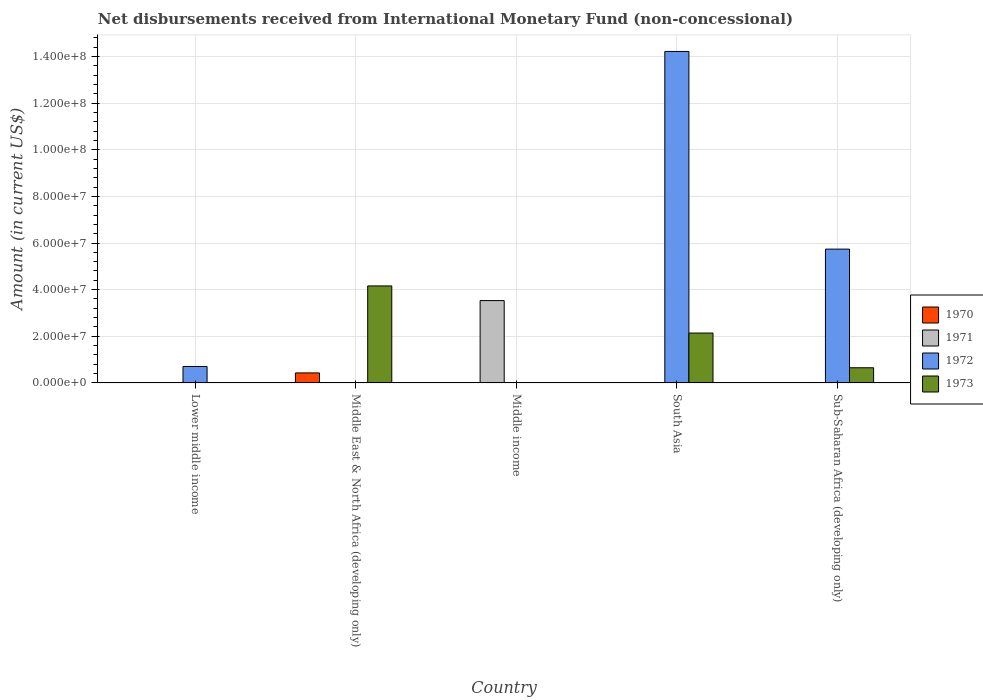What is the label of the 1st group of bars from the left?
Give a very brief answer. Lower middle income. In how many cases, is the number of bars for a given country not equal to the number of legend labels?
Your answer should be compact. 5. What is the amount of disbursements received from International Monetary Fund in 1970 in Lower middle income?
Your answer should be very brief. 0. Across all countries, what is the maximum amount of disbursements received from International Monetary Fund in 1970?
Keep it short and to the point. 4.30e+06. In which country was the amount of disbursements received from International Monetary Fund in 1972 maximum?
Provide a succinct answer. South Asia. What is the total amount of disbursements received from International Monetary Fund in 1971 in the graph?
Offer a very short reply. 3.53e+07. What is the difference between the amount of disbursements received from International Monetary Fund in 1972 in Lower middle income and that in Sub-Saharan Africa (developing only)?
Make the answer very short. -5.03e+07. What is the difference between the amount of disbursements received from International Monetary Fund in 1971 in Middle income and the amount of disbursements received from International Monetary Fund in 1972 in Middle East & North Africa (developing only)?
Keep it short and to the point. 3.53e+07. What is the average amount of disbursements received from International Monetary Fund in 1971 per country?
Your response must be concise. 7.06e+06. What is the difference between the amount of disbursements received from International Monetary Fund of/in 1972 and amount of disbursements received from International Monetary Fund of/in 1973 in Sub-Saharan Africa (developing only)?
Your response must be concise. 5.09e+07. What is the difference between the highest and the second highest amount of disbursements received from International Monetary Fund in 1972?
Give a very brief answer. 8.48e+07. What is the difference between the highest and the lowest amount of disbursements received from International Monetary Fund in 1971?
Your answer should be compact. 3.53e+07. In how many countries, is the amount of disbursements received from International Monetary Fund in 1971 greater than the average amount of disbursements received from International Monetary Fund in 1971 taken over all countries?
Give a very brief answer. 1. How many countries are there in the graph?
Keep it short and to the point. 5. Does the graph contain any zero values?
Your answer should be very brief. Yes. Does the graph contain grids?
Offer a terse response. Yes. Where does the legend appear in the graph?
Provide a short and direct response. Center right. What is the title of the graph?
Offer a very short reply. Net disbursements received from International Monetary Fund (non-concessional). What is the label or title of the X-axis?
Offer a terse response. Country. What is the label or title of the Y-axis?
Your response must be concise. Amount (in current US$). What is the Amount (in current US$) in 1972 in Lower middle income?
Give a very brief answer. 7.06e+06. What is the Amount (in current US$) in 1970 in Middle East & North Africa (developing only)?
Keep it short and to the point. 4.30e+06. What is the Amount (in current US$) of 1971 in Middle East & North Africa (developing only)?
Make the answer very short. 0. What is the Amount (in current US$) of 1973 in Middle East & North Africa (developing only)?
Your answer should be compact. 4.16e+07. What is the Amount (in current US$) in 1971 in Middle income?
Provide a succinct answer. 3.53e+07. What is the Amount (in current US$) in 1972 in Middle income?
Your answer should be very brief. 0. What is the Amount (in current US$) of 1971 in South Asia?
Your answer should be compact. 0. What is the Amount (in current US$) in 1972 in South Asia?
Ensure brevity in your answer.  1.42e+08. What is the Amount (in current US$) of 1973 in South Asia?
Your answer should be very brief. 2.14e+07. What is the Amount (in current US$) of 1971 in Sub-Saharan Africa (developing only)?
Your answer should be very brief. 0. What is the Amount (in current US$) of 1972 in Sub-Saharan Africa (developing only)?
Ensure brevity in your answer.  5.74e+07. What is the Amount (in current US$) in 1973 in Sub-Saharan Africa (developing only)?
Offer a terse response. 6.51e+06. Across all countries, what is the maximum Amount (in current US$) of 1970?
Provide a succinct answer. 4.30e+06. Across all countries, what is the maximum Amount (in current US$) in 1971?
Provide a short and direct response. 3.53e+07. Across all countries, what is the maximum Amount (in current US$) in 1972?
Offer a very short reply. 1.42e+08. Across all countries, what is the maximum Amount (in current US$) of 1973?
Give a very brief answer. 4.16e+07. Across all countries, what is the minimum Amount (in current US$) of 1970?
Offer a very short reply. 0. Across all countries, what is the minimum Amount (in current US$) of 1971?
Make the answer very short. 0. What is the total Amount (in current US$) of 1970 in the graph?
Give a very brief answer. 4.30e+06. What is the total Amount (in current US$) of 1971 in the graph?
Keep it short and to the point. 3.53e+07. What is the total Amount (in current US$) of 1972 in the graph?
Your response must be concise. 2.07e+08. What is the total Amount (in current US$) in 1973 in the graph?
Offer a terse response. 6.95e+07. What is the difference between the Amount (in current US$) of 1972 in Lower middle income and that in South Asia?
Offer a very short reply. -1.35e+08. What is the difference between the Amount (in current US$) in 1972 in Lower middle income and that in Sub-Saharan Africa (developing only)?
Offer a terse response. -5.03e+07. What is the difference between the Amount (in current US$) of 1973 in Middle East & North Africa (developing only) and that in South Asia?
Give a very brief answer. 2.02e+07. What is the difference between the Amount (in current US$) in 1973 in Middle East & North Africa (developing only) and that in Sub-Saharan Africa (developing only)?
Your answer should be very brief. 3.51e+07. What is the difference between the Amount (in current US$) of 1972 in South Asia and that in Sub-Saharan Africa (developing only)?
Your response must be concise. 8.48e+07. What is the difference between the Amount (in current US$) in 1973 in South Asia and that in Sub-Saharan Africa (developing only)?
Keep it short and to the point. 1.49e+07. What is the difference between the Amount (in current US$) of 1972 in Lower middle income and the Amount (in current US$) of 1973 in Middle East & North Africa (developing only)?
Your answer should be compact. -3.45e+07. What is the difference between the Amount (in current US$) of 1972 in Lower middle income and the Amount (in current US$) of 1973 in South Asia?
Give a very brief answer. -1.43e+07. What is the difference between the Amount (in current US$) in 1972 in Lower middle income and the Amount (in current US$) in 1973 in Sub-Saharan Africa (developing only)?
Make the answer very short. 5.46e+05. What is the difference between the Amount (in current US$) in 1970 in Middle East & North Africa (developing only) and the Amount (in current US$) in 1971 in Middle income?
Offer a very short reply. -3.10e+07. What is the difference between the Amount (in current US$) in 1970 in Middle East & North Africa (developing only) and the Amount (in current US$) in 1972 in South Asia?
Your answer should be compact. -1.38e+08. What is the difference between the Amount (in current US$) of 1970 in Middle East & North Africa (developing only) and the Amount (in current US$) of 1973 in South Asia?
Your answer should be very brief. -1.71e+07. What is the difference between the Amount (in current US$) in 1970 in Middle East & North Africa (developing only) and the Amount (in current US$) in 1972 in Sub-Saharan Africa (developing only)?
Your answer should be very brief. -5.31e+07. What is the difference between the Amount (in current US$) of 1970 in Middle East & North Africa (developing only) and the Amount (in current US$) of 1973 in Sub-Saharan Africa (developing only)?
Keep it short and to the point. -2.21e+06. What is the difference between the Amount (in current US$) of 1971 in Middle income and the Amount (in current US$) of 1972 in South Asia?
Your answer should be compact. -1.07e+08. What is the difference between the Amount (in current US$) in 1971 in Middle income and the Amount (in current US$) in 1973 in South Asia?
Your answer should be compact. 1.39e+07. What is the difference between the Amount (in current US$) in 1971 in Middle income and the Amount (in current US$) in 1972 in Sub-Saharan Africa (developing only)?
Your response must be concise. -2.21e+07. What is the difference between the Amount (in current US$) in 1971 in Middle income and the Amount (in current US$) in 1973 in Sub-Saharan Africa (developing only)?
Give a very brief answer. 2.88e+07. What is the difference between the Amount (in current US$) of 1972 in South Asia and the Amount (in current US$) of 1973 in Sub-Saharan Africa (developing only)?
Ensure brevity in your answer.  1.36e+08. What is the average Amount (in current US$) in 1970 per country?
Your answer should be very brief. 8.60e+05. What is the average Amount (in current US$) in 1971 per country?
Your answer should be compact. 7.06e+06. What is the average Amount (in current US$) in 1972 per country?
Offer a very short reply. 4.13e+07. What is the average Amount (in current US$) in 1973 per country?
Make the answer very short. 1.39e+07. What is the difference between the Amount (in current US$) of 1970 and Amount (in current US$) of 1973 in Middle East & North Africa (developing only)?
Your answer should be compact. -3.73e+07. What is the difference between the Amount (in current US$) of 1972 and Amount (in current US$) of 1973 in South Asia?
Keep it short and to the point. 1.21e+08. What is the difference between the Amount (in current US$) of 1972 and Amount (in current US$) of 1973 in Sub-Saharan Africa (developing only)?
Make the answer very short. 5.09e+07. What is the ratio of the Amount (in current US$) of 1972 in Lower middle income to that in South Asia?
Make the answer very short. 0.05. What is the ratio of the Amount (in current US$) of 1972 in Lower middle income to that in Sub-Saharan Africa (developing only)?
Your answer should be compact. 0.12. What is the ratio of the Amount (in current US$) of 1973 in Middle East & North Africa (developing only) to that in South Asia?
Offer a terse response. 1.94. What is the ratio of the Amount (in current US$) of 1973 in Middle East & North Africa (developing only) to that in Sub-Saharan Africa (developing only)?
Offer a terse response. 6.39. What is the ratio of the Amount (in current US$) of 1972 in South Asia to that in Sub-Saharan Africa (developing only)?
Your response must be concise. 2.48. What is the ratio of the Amount (in current US$) in 1973 in South Asia to that in Sub-Saharan Africa (developing only)?
Ensure brevity in your answer.  3.29. What is the difference between the highest and the second highest Amount (in current US$) of 1972?
Offer a very short reply. 8.48e+07. What is the difference between the highest and the second highest Amount (in current US$) of 1973?
Offer a very short reply. 2.02e+07. What is the difference between the highest and the lowest Amount (in current US$) in 1970?
Make the answer very short. 4.30e+06. What is the difference between the highest and the lowest Amount (in current US$) of 1971?
Give a very brief answer. 3.53e+07. What is the difference between the highest and the lowest Amount (in current US$) in 1972?
Offer a terse response. 1.42e+08. What is the difference between the highest and the lowest Amount (in current US$) of 1973?
Your answer should be compact. 4.16e+07. 